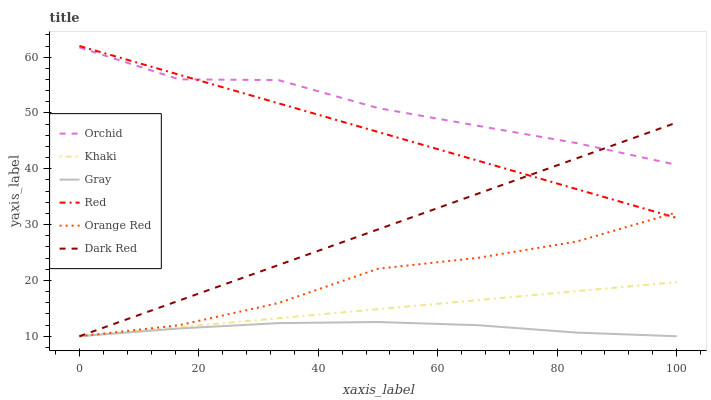Does Gray have the minimum area under the curve?
Answer yes or no. Yes. Does Orchid have the maximum area under the curve?
Answer yes or no. Yes. Does Khaki have the minimum area under the curve?
Answer yes or no. No. Does Khaki have the maximum area under the curve?
Answer yes or no. No. Is Khaki the smoothest?
Answer yes or no. Yes. Is Orchid the roughest?
Answer yes or no. Yes. Is Dark Red the smoothest?
Answer yes or no. No. Is Dark Red the roughest?
Answer yes or no. No. Does Gray have the lowest value?
Answer yes or no. Yes. Does Red have the lowest value?
Answer yes or no. No. Does Red have the highest value?
Answer yes or no. Yes. Does Khaki have the highest value?
Answer yes or no. No. Is Orange Red less than Orchid?
Answer yes or no. Yes. Is Orchid greater than Khaki?
Answer yes or no. Yes. Does Orchid intersect Dark Red?
Answer yes or no. Yes. Is Orchid less than Dark Red?
Answer yes or no. No. Is Orchid greater than Dark Red?
Answer yes or no. No. Does Orange Red intersect Orchid?
Answer yes or no. No. 